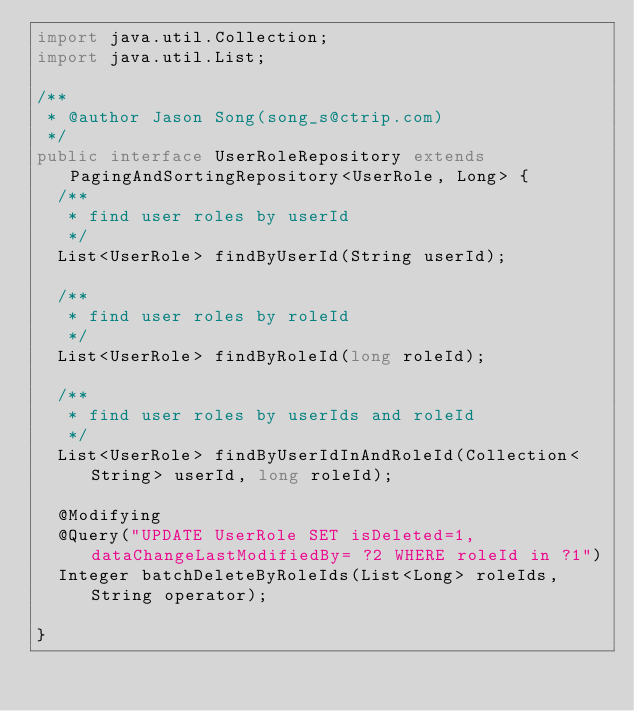Convert code to text. <code><loc_0><loc_0><loc_500><loc_500><_Java_>import java.util.Collection;
import java.util.List;

/**
 * @author Jason Song(song_s@ctrip.com)
 */
public interface UserRoleRepository extends PagingAndSortingRepository<UserRole, Long> {
  /**
   * find user roles by userId
   */
  List<UserRole> findByUserId(String userId);

  /**
   * find user roles by roleId
   */
  List<UserRole> findByRoleId(long roleId);

  /**
   * find user roles by userIds and roleId
   */
  List<UserRole> findByUserIdInAndRoleId(Collection<String> userId, long roleId);

  @Modifying
  @Query("UPDATE UserRole SET isDeleted=1, dataChangeLastModifiedBy= ?2 WHERE roleId in ?1")
  Integer batchDeleteByRoleIds(List<Long> roleIds, String operator);

}
</code> 